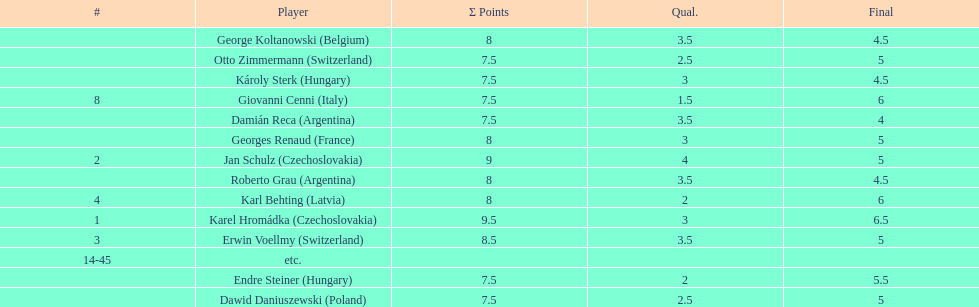Parse the full table. {'header': ['#', 'Player', 'Σ Points', 'Qual.', 'Final'], 'rows': [['', 'George Koltanowski\xa0(Belgium)', '8', '3.5', '4.5'], ['', 'Otto Zimmermann\xa0(Switzerland)', '7.5', '2.5', '5'], ['', 'Károly Sterk\xa0(Hungary)', '7.5', '3', '4.5'], ['8', 'Giovanni Cenni\xa0(Italy)', '7.5', '1.5', '6'], ['', 'Damián Reca\xa0(Argentina)', '7.5', '3.5', '4'], ['', 'Georges Renaud\xa0(France)', '8', '3', '5'], ['2', 'Jan Schulz\xa0(Czechoslovakia)', '9', '4', '5'], ['', 'Roberto Grau\xa0(Argentina)', '8', '3.5', '4.5'], ['4', 'Karl Behting\xa0(Latvia)', '8', '2', '6'], ['1', 'Karel Hromádka\xa0(Czechoslovakia)', '9.5', '3', '6.5'], ['3', 'Erwin Voellmy\xa0(Switzerland)', '8.5', '3.5', '5'], ['14-45', 'etc.', '', '', ''], ['', 'Endre Steiner\xa0(Hungary)', '7.5', '2', '5.5'], ['', 'Dawid Daniuszewski\xa0(Poland)', '7.5', '2.5', '5']]} Which player had the largest number of &#931; points? Karel Hromádka. 